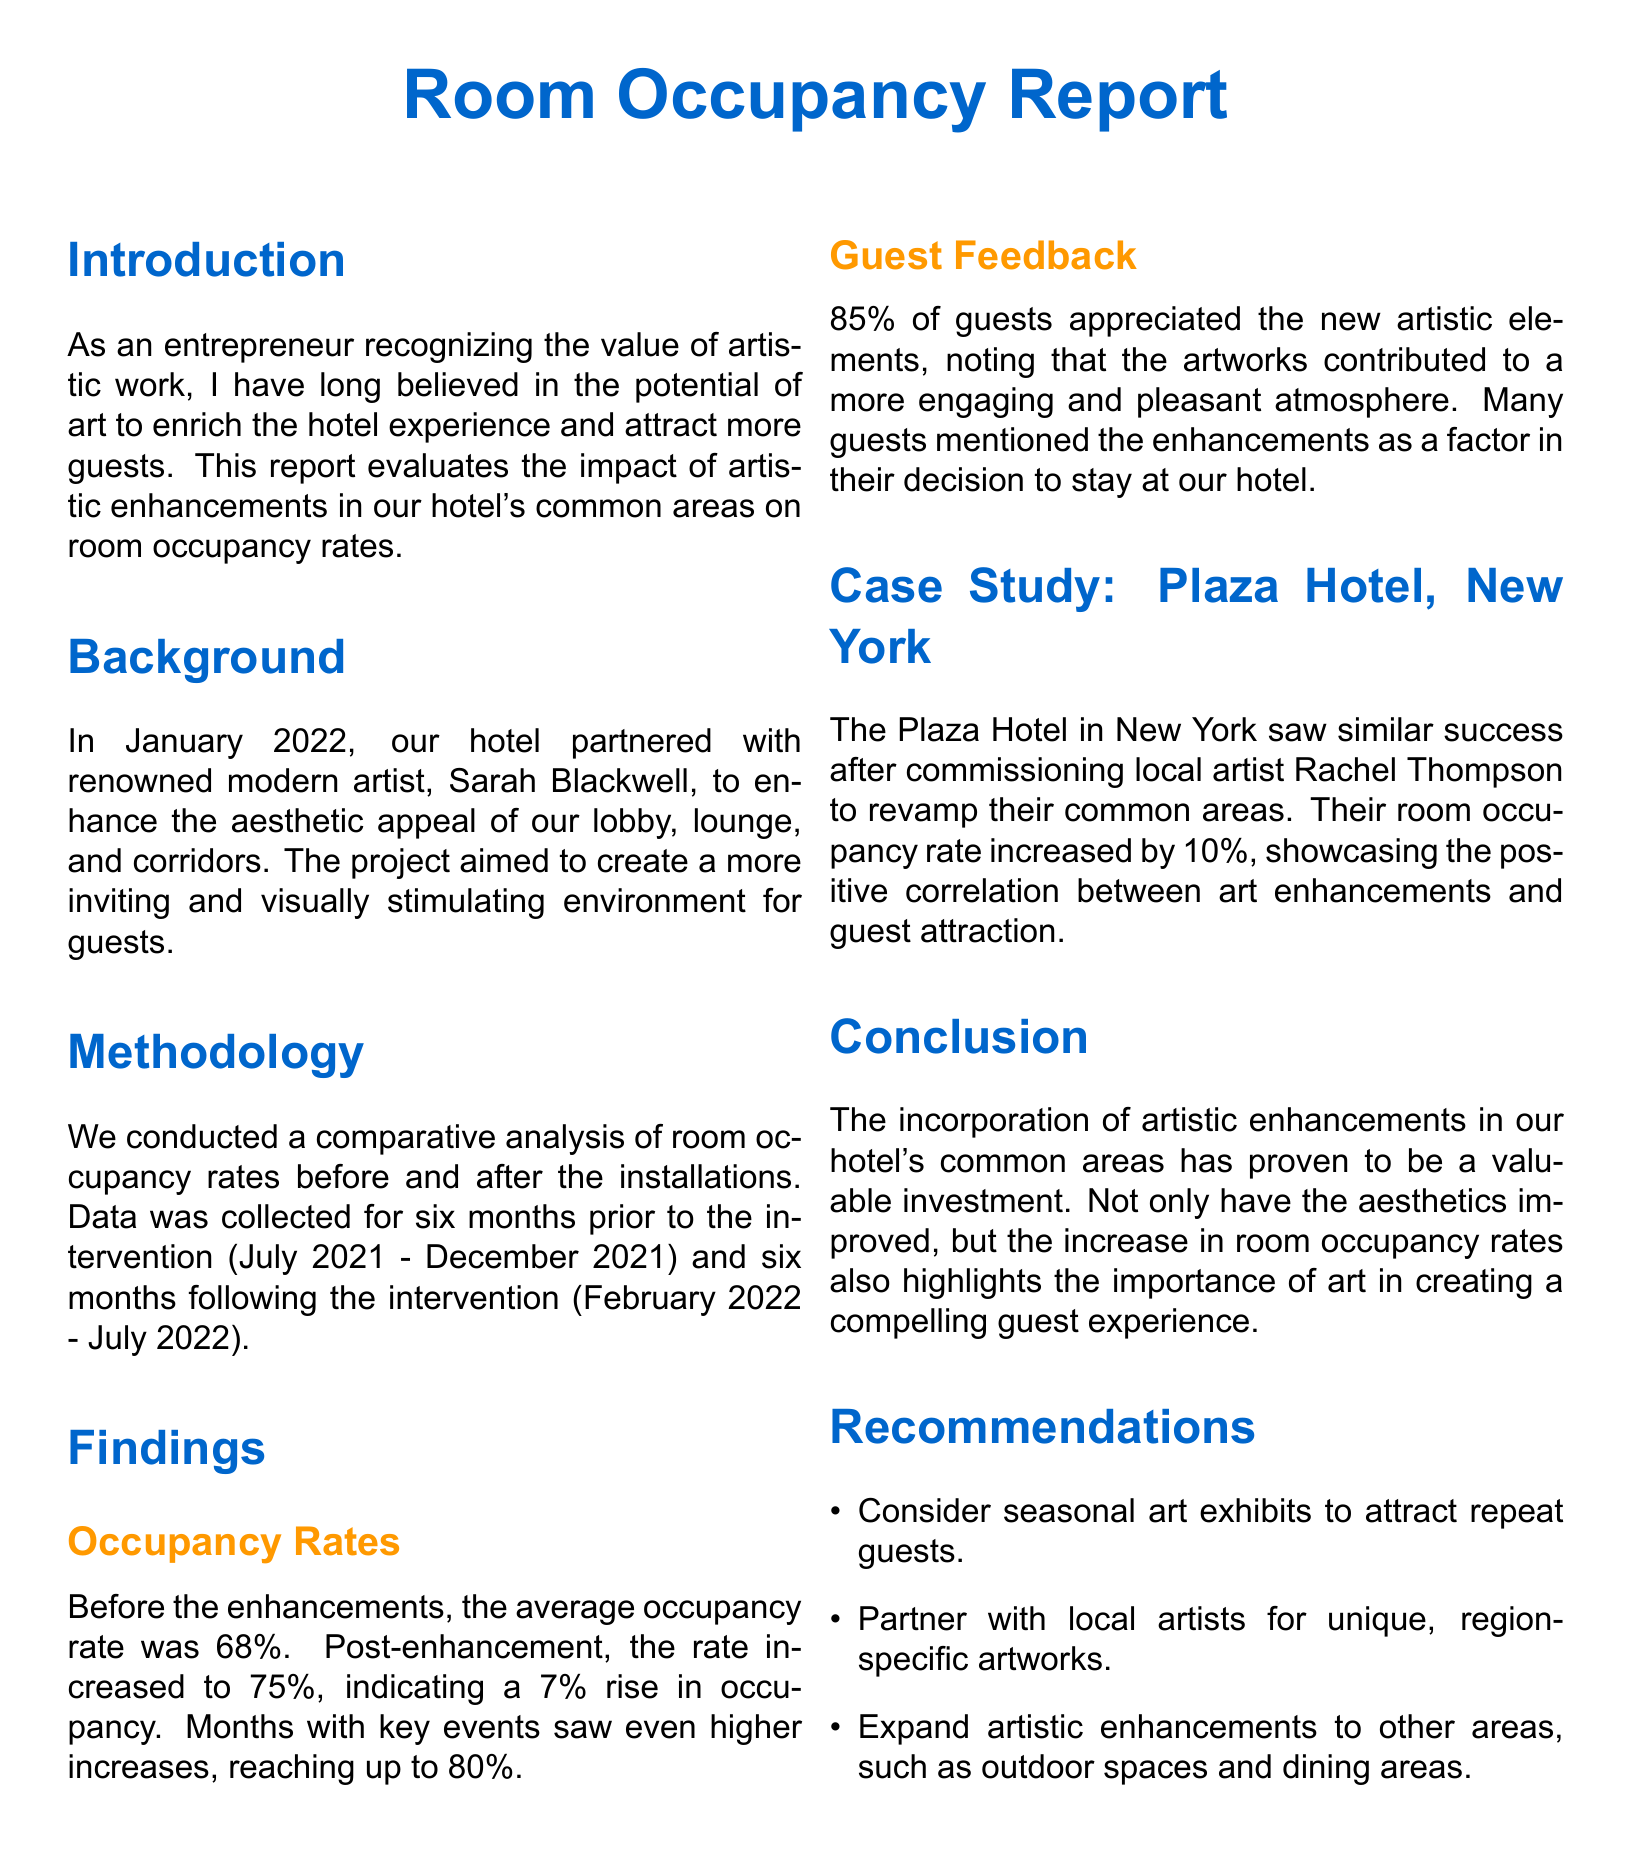What was the average occupancy rate before enhancements? The document states that before the enhancements, the average occupancy rate was 68%.
Answer: 68% What was the average occupancy rate after enhancements? According to the findings, the average occupancy rate after enhancements increased to 75%.
Answer: 75% What percentage of guests appreciated the new artistic elements? The report mentions that 85% of guests appreciated the new artistic elements.
Answer: 85% How many months of data were collected before the intervention? The report indicates that six months of data was collected prior to the intervention.
Answer: Six months What was the increase in occupancy rate after enhancements? The occupancy rate increased by 7% following the enhancements.
Answer: 7% What positive outcome did the Plaza Hotel see after artistic enhancements? The Plaza Hotel in New York saw their room occupancy rate increase by 10% after the enhancements.
Answer: 10% What is one recommendation made in the report? The report suggests considering seasonal art exhibits to attract repeat guests.
Answer: Seasonal art exhibits How long did the artistic enhancement project last? The project was completed in January 2022 as stated in the background section of the report.
Answer: January 2022 What is the main conclusion of the report? The conclusion states that the incorporation of artistic enhancements has proven to be a valuable investment.
Answer: Valuable investment 